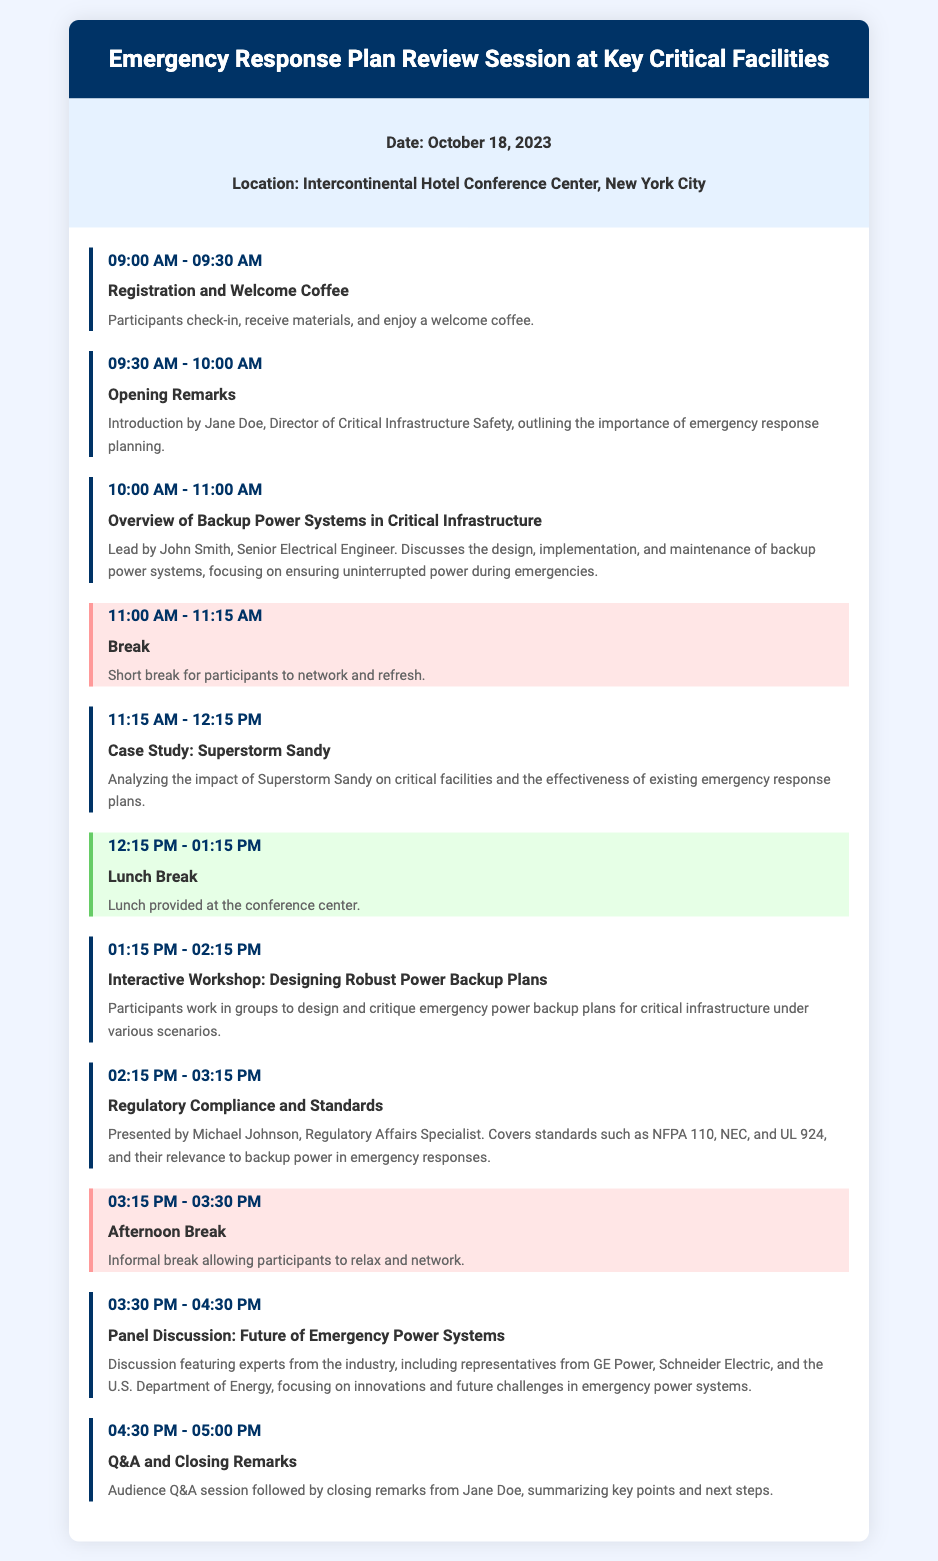What date is the Emergency Response Plan Review Session scheduled for? The date is specified in the document as October 18, 2023.
Answer: October 18, 2023 Where is the location of the session? The location of the event is mentioned as the Intercontinental Hotel Conference Center, New York City.
Answer: Intercontinental Hotel Conference Center, New York City Who is leading the session on Backup Power Systems? The document names John Smith as the leader of the session regarding Backup Power Systems.
Answer: John Smith What time does the lunch break start? The document states that lunch is scheduled to begin at 12:15 PM.
Answer: 12:15 PM What is one of the regulatory standards discussed during the session? The document references NFPA 110 as one of the standards related to backup power.
Answer: NFPA 110 What activity takes place immediately after the morning break? The agenda lists the Case Study on Superstorm Sandy right after the break.
Answer: Case Study: Superstorm Sandy How long is the interactive workshop set for? The document indicates that the interactive workshop spans one hour, from 01:15 PM to 02:15 PM.
Answer: One hour Who will give the closing remarks? The closing remarks are summarized by Jane Doe, as stated in the schedule.
Answer: Jane Doe What type of session is scheduled at 03:30 PM? The document specifies a Panel Discussion scheduled at that time.
Answer: Panel Discussion 